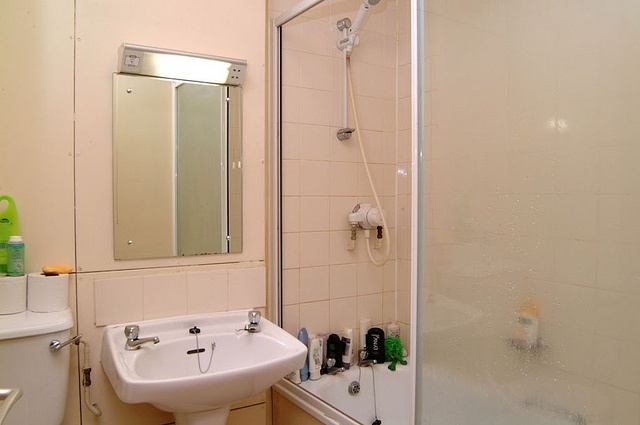Describe the objects in this image and their specific colors. I can see sink in tan, lightgray, gray, and darkgray tones, toilet in tan, darkgray, gray, and lightgray tones, bottle in tan, green, and olive tones, bottle in tan, black, gray, and maroon tones, and bottle in tan and gray tones in this image. 